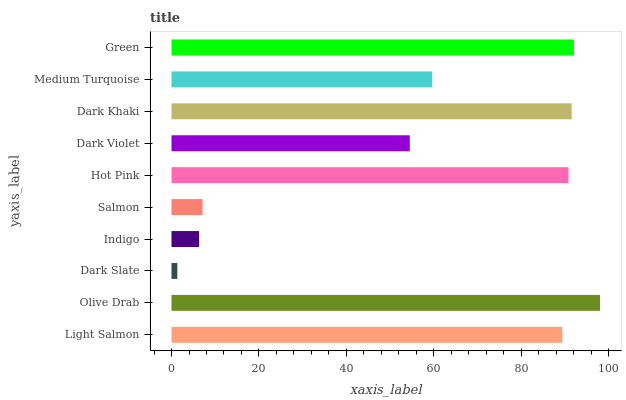Is Dark Slate the minimum?
Answer yes or no. Yes. Is Olive Drab the maximum?
Answer yes or no. Yes. Is Olive Drab the minimum?
Answer yes or no. No. Is Dark Slate the maximum?
Answer yes or no. No. Is Olive Drab greater than Dark Slate?
Answer yes or no. Yes. Is Dark Slate less than Olive Drab?
Answer yes or no. Yes. Is Dark Slate greater than Olive Drab?
Answer yes or no. No. Is Olive Drab less than Dark Slate?
Answer yes or no. No. Is Light Salmon the high median?
Answer yes or no. Yes. Is Medium Turquoise the low median?
Answer yes or no. Yes. Is Dark Khaki the high median?
Answer yes or no. No. Is Hot Pink the low median?
Answer yes or no. No. 